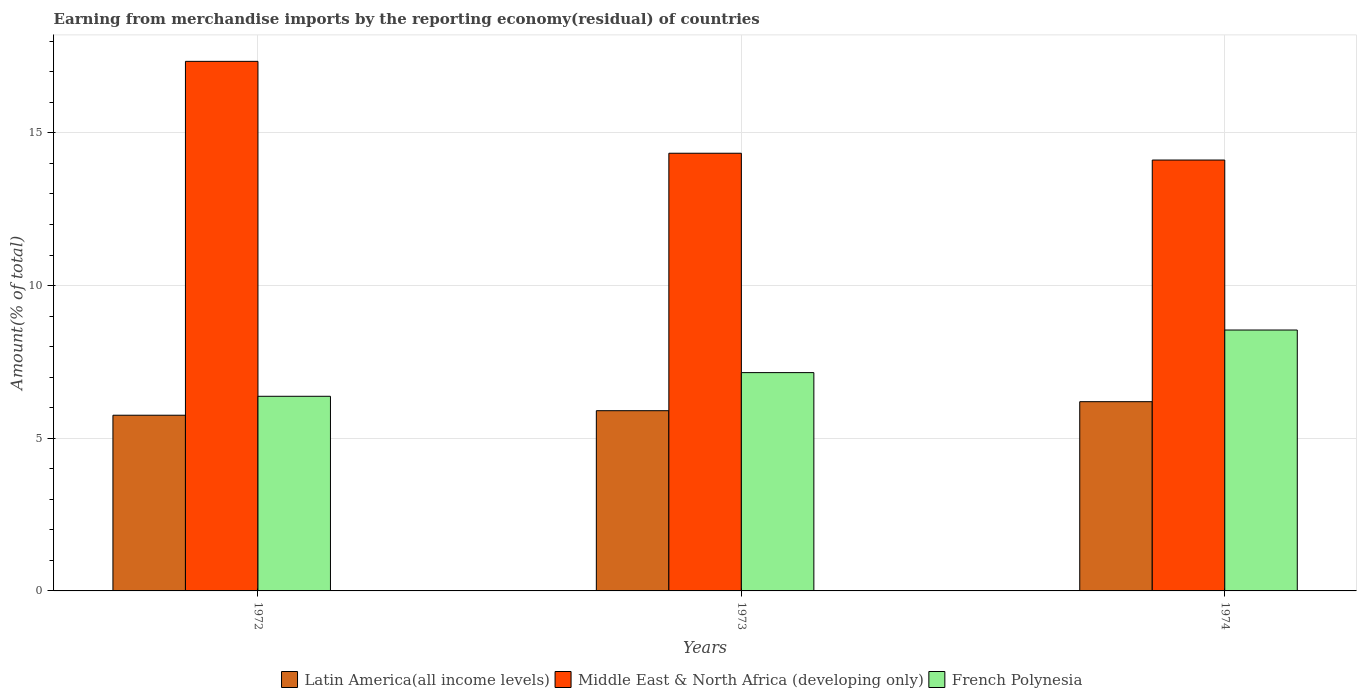How many different coloured bars are there?
Your answer should be compact. 3. Are the number of bars per tick equal to the number of legend labels?
Ensure brevity in your answer.  Yes. How many bars are there on the 2nd tick from the right?
Your response must be concise. 3. What is the label of the 3rd group of bars from the left?
Provide a short and direct response. 1974. What is the percentage of amount earned from merchandise imports in Latin America(all income levels) in 1972?
Give a very brief answer. 5.75. Across all years, what is the maximum percentage of amount earned from merchandise imports in Middle East & North Africa (developing only)?
Provide a short and direct response. 17.34. Across all years, what is the minimum percentage of amount earned from merchandise imports in French Polynesia?
Give a very brief answer. 6.37. In which year was the percentage of amount earned from merchandise imports in French Polynesia maximum?
Your response must be concise. 1974. What is the total percentage of amount earned from merchandise imports in Latin America(all income levels) in the graph?
Your answer should be very brief. 17.86. What is the difference between the percentage of amount earned from merchandise imports in Latin America(all income levels) in 1972 and that in 1973?
Offer a terse response. -0.15. What is the difference between the percentage of amount earned from merchandise imports in Middle East & North Africa (developing only) in 1973 and the percentage of amount earned from merchandise imports in French Polynesia in 1972?
Give a very brief answer. 7.96. What is the average percentage of amount earned from merchandise imports in Latin America(all income levels) per year?
Your response must be concise. 5.95. In the year 1972, what is the difference between the percentage of amount earned from merchandise imports in French Polynesia and percentage of amount earned from merchandise imports in Middle East & North Africa (developing only)?
Provide a succinct answer. -10.97. What is the ratio of the percentage of amount earned from merchandise imports in Middle East & North Africa (developing only) in 1972 to that in 1973?
Give a very brief answer. 1.21. What is the difference between the highest and the second highest percentage of amount earned from merchandise imports in French Polynesia?
Ensure brevity in your answer.  1.39. What is the difference between the highest and the lowest percentage of amount earned from merchandise imports in Middle East & North Africa (developing only)?
Provide a short and direct response. 3.23. In how many years, is the percentage of amount earned from merchandise imports in French Polynesia greater than the average percentage of amount earned from merchandise imports in French Polynesia taken over all years?
Keep it short and to the point. 1. Is the sum of the percentage of amount earned from merchandise imports in Middle East & North Africa (developing only) in 1972 and 1974 greater than the maximum percentage of amount earned from merchandise imports in Latin America(all income levels) across all years?
Offer a terse response. Yes. What does the 2nd bar from the left in 1972 represents?
Your response must be concise. Middle East & North Africa (developing only). What does the 1st bar from the right in 1974 represents?
Offer a terse response. French Polynesia. Are the values on the major ticks of Y-axis written in scientific E-notation?
Offer a very short reply. No. Does the graph contain any zero values?
Your answer should be compact. No. Does the graph contain grids?
Your answer should be very brief. Yes. How many legend labels are there?
Offer a very short reply. 3. How are the legend labels stacked?
Give a very brief answer. Horizontal. What is the title of the graph?
Keep it short and to the point. Earning from merchandise imports by the reporting economy(residual) of countries. Does "Denmark" appear as one of the legend labels in the graph?
Your response must be concise. No. What is the label or title of the Y-axis?
Provide a short and direct response. Amount(% of total). What is the Amount(% of total) of Latin America(all income levels) in 1972?
Your response must be concise. 5.75. What is the Amount(% of total) in Middle East & North Africa (developing only) in 1972?
Keep it short and to the point. 17.34. What is the Amount(% of total) of French Polynesia in 1972?
Your response must be concise. 6.37. What is the Amount(% of total) of Latin America(all income levels) in 1973?
Your response must be concise. 5.9. What is the Amount(% of total) of Middle East & North Africa (developing only) in 1973?
Your answer should be compact. 14.33. What is the Amount(% of total) in French Polynesia in 1973?
Ensure brevity in your answer.  7.15. What is the Amount(% of total) of Latin America(all income levels) in 1974?
Your answer should be very brief. 6.2. What is the Amount(% of total) in Middle East & North Africa (developing only) in 1974?
Provide a short and direct response. 14.11. What is the Amount(% of total) in French Polynesia in 1974?
Offer a terse response. 8.54. Across all years, what is the maximum Amount(% of total) in Latin America(all income levels)?
Offer a terse response. 6.2. Across all years, what is the maximum Amount(% of total) in Middle East & North Africa (developing only)?
Ensure brevity in your answer.  17.34. Across all years, what is the maximum Amount(% of total) in French Polynesia?
Make the answer very short. 8.54. Across all years, what is the minimum Amount(% of total) in Latin America(all income levels)?
Offer a terse response. 5.75. Across all years, what is the minimum Amount(% of total) in Middle East & North Africa (developing only)?
Your response must be concise. 14.11. Across all years, what is the minimum Amount(% of total) in French Polynesia?
Your answer should be compact. 6.37. What is the total Amount(% of total) of Latin America(all income levels) in the graph?
Ensure brevity in your answer.  17.86. What is the total Amount(% of total) of Middle East & North Africa (developing only) in the graph?
Provide a succinct answer. 45.79. What is the total Amount(% of total) in French Polynesia in the graph?
Your answer should be very brief. 22.07. What is the difference between the Amount(% of total) of Latin America(all income levels) in 1972 and that in 1973?
Give a very brief answer. -0.15. What is the difference between the Amount(% of total) of Middle East & North Africa (developing only) in 1972 and that in 1973?
Make the answer very short. 3.01. What is the difference between the Amount(% of total) in French Polynesia in 1972 and that in 1973?
Offer a terse response. -0.78. What is the difference between the Amount(% of total) of Latin America(all income levels) in 1972 and that in 1974?
Your answer should be very brief. -0.44. What is the difference between the Amount(% of total) of Middle East & North Africa (developing only) in 1972 and that in 1974?
Provide a succinct answer. 3.23. What is the difference between the Amount(% of total) in French Polynesia in 1972 and that in 1974?
Offer a terse response. -2.17. What is the difference between the Amount(% of total) in Latin America(all income levels) in 1973 and that in 1974?
Provide a succinct answer. -0.3. What is the difference between the Amount(% of total) in Middle East & North Africa (developing only) in 1973 and that in 1974?
Provide a succinct answer. 0.22. What is the difference between the Amount(% of total) of French Polynesia in 1973 and that in 1974?
Provide a succinct answer. -1.39. What is the difference between the Amount(% of total) in Latin America(all income levels) in 1972 and the Amount(% of total) in Middle East & North Africa (developing only) in 1973?
Give a very brief answer. -8.58. What is the difference between the Amount(% of total) of Latin America(all income levels) in 1972 and the Amount(% of total) of French Polynesia in 1973?
Your answer should be compact. -1.4. What is the difference between the Amount(% of total) of Middle East & North Africa (developing only) in 1972 and the Amount(% of total) of French Polynesia in 1973?
Your response must be concise. 10.19. What is the difference between the Amount(% of total) in Latin America(all income levels) in 1972 and the Amount(% of total) in Middle East & North Africa (developing only) in 1974?
Give a very brief answer. -8.36. What is the difference between the Amount(% of total) in Latin America(all income levels) in 1972 and the Amount(% of total) in French Polynesia in 1974?
Your answer should be very brief. -2.79. What is the difference between the Amount(% of total) of Middle East & North Africa (developing only) in 1972 and the Amount(% of total) of French Polynesia in 1974?
Give a very brief answer. 8.8. What is the difference between the Amount(% of total) in Latin America(all income levels) in 1973 and the Amount(% of total) in Middle East & North Africa (developing only) in 1974?
Make the answer very short. -8.21. What is the difference between the Amount(% of total) of Latin America(all income levels) in 1973 and the Amount(% of total) of French Polynesia in 1974?
Your answer should be compact. -2.64. What is the difference between the Amount(% of total) of Middle East & North Africa (developing only) in 1973 and the Amount(% of total) of French Polynesia in 1974?
Your answer should be very brief. 5.79. What is the average Amount(% of total) of Latin America(all income levels) per year?
Make the answer very short. 5.95. What is the average Amount(% of total) in Middle East & North Africa (developing only) per year?
Provide a short and direct response. 15.26. What is the average Amount(% of total) of French Polynesia per year?
Offer a very short reply. 7.36. In the year 1972, what is the difference between the Amount(% of total) of Latin America(all income levels) and Amount(% of total) of Middle East & North Africa (developing only)?
Give a very brief answer. -11.59. In the year 1972, what is the difference between the Amount(% of total) in Latin America(all income levels) and Amount(% of total) in French Polynesia?
Your response must be concise. -0.62. In the year 1972, what is the difference between the Amount(% of total) in Middle East & North Africa (developing only) and Amount(% of total) in French Polynesia?
Provide a succinct answer. 10.97. In the year 1973, what is the difference between the Amount(% of total) in Latin America(all income levels) and Amount(% of total) in Middle East & North Africa (developing only)?
Ensure brevity in your answer.  -8.43. In the year 1973, what is the difference between the Amount(% of total) of Latin America(all income levels) and Amount(% of total) of French Polynesia?
Ensure brevity in your answer.  -1.25. In the year 1973, what is the difference between the Amount(% of total) of Middle East & North Africa (developing only) and Amount(% of total) of French Polynesia?
Provide a succinct answer. 7.18. In the year 1974, what is the difference between the Amount(% of total) in Latin America(all income levels) and Amount(% of total) in Middle East & North Africa (developing only)?
Your answer should be very brief. -7.91. In the year 1974, what is the difference between the Amount(% of total) in Latin America(all income levels) and Amount(% of total) in French Polynesia?
Provide a succinct answer. -2.35. In the year 1974, what is the difference between the Amount(% of total) in Middle East & North Africa (developing only) and Amount(% of total) in French Polynesia?
Your answer should be compact. 5.57. What is the ratio of the Amount(% of total) of Latin America(all income levels) in 1972 to that in 1973?
Give a very brief answer. 0.97. What is the ratio of the Amount(% of total) in Middle East & North Africa (developing only) in 1972 to that in 1973?
Your answer should be compact. 1.21. What is the ratio of the Amount(% of total) in French Polynesia in 1972 to that in 1973?
Provide a succinct answer. 0.89. What is the ratio of the Amount(% of total) of Latin America(all income levels) in 1972 to that in 1974?
Your answer should be very brief. 0.93. What is the ratio of the Amount(% of total) in Middle East & North Africa (developing only) in 1972 to that in 1974?
Make the answer very short. 1.23. What is the ratio of the Amount(% of total) in French Polynesia in 1972 to that in 1974?
Offer a terse response. 0.75. What is the ratio of the Amount(% of total) in Latin America(all income levels) in 1973 to that in 1974?
Your answer should be compact. 0.95. What is the ratio of the Amount(% of total) of Middle East & North Africa (developing only) in 1973 to that in 1974?
Give a very brief answer. 1.02. What is the ratio of the Amount(% of total) of French Polynesia in 1973 to that in 1974?
Your answer should be very brief. 0.84. What is the difference between the highest and the second highest Amount(% of total) of Latin America(all income levels)?
Your response must be concise. 0.3. What is the difference between the highest and the second highest Amount(% of total) in Middle East & North Africa (developing only)?
Offer a very short reply. 3.01. What is the difference between the highest and the second highest Amount(% of total) of French Polynesia?
Provide a succinct answer. 1.39. What is the difference between the highest and the lowest Amount(% of total) of Latin America(all income levels)?
Offer a very short reply. 0.44. What is the difference between the highest and the lowest Amount(% of total) of Middle East & North Africa (developing only)?
Make the answer very short. 3.23. What is the difference between the highest and the lowest Amount(% of total) in French Polynesia?
Keep it short and to the point. 2.17. 